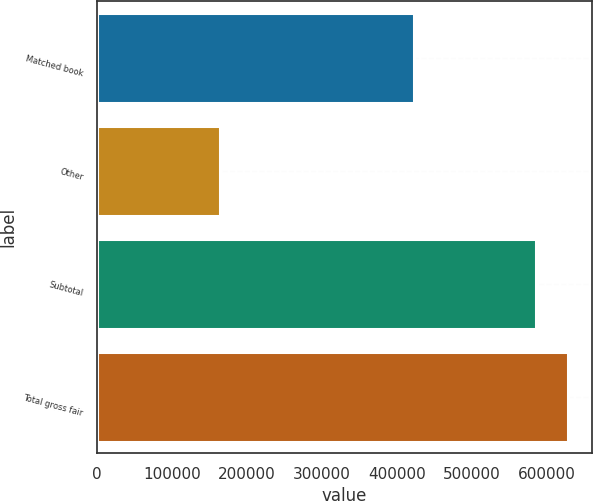Convert chart. <chart><loc_0><loc_0><loc_500><loc_500><bar_chart><fcel>Matched book<fcel>Other<fcel>Subtotal<fcel>Total gross fair<nl><fcel>422196<fcel>163433<fcel>586249<fcel>628670<nl></chart> 